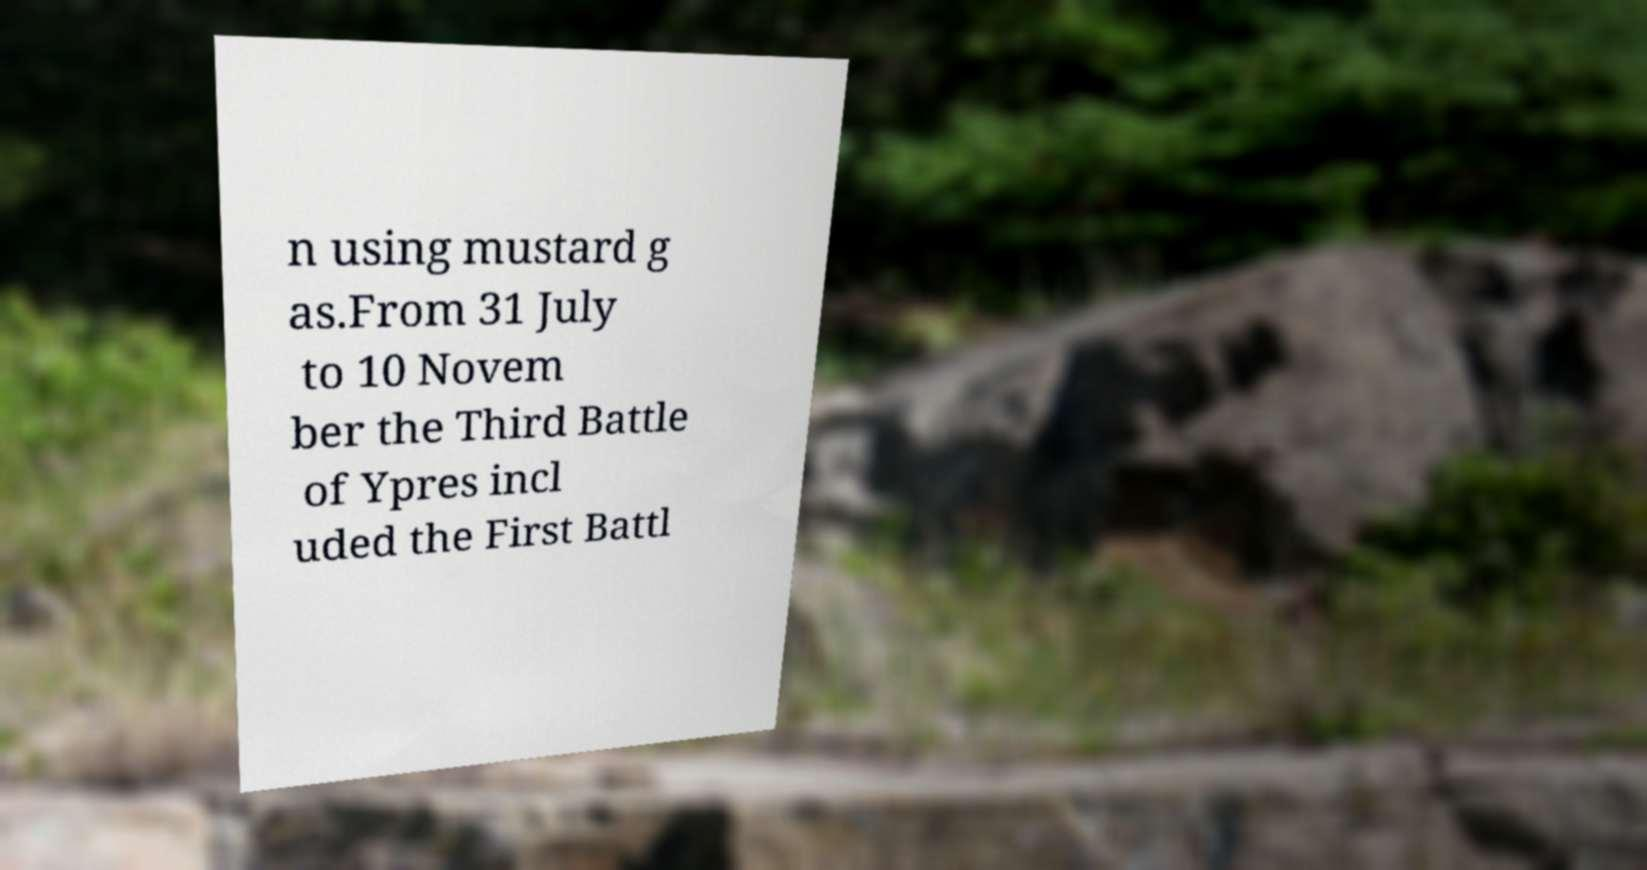Please identify and transcribe the text found in this image. n using mustard g as.From 31 July to 10 Novem ber the Third Battle of Ypres incl uded the First Battl 